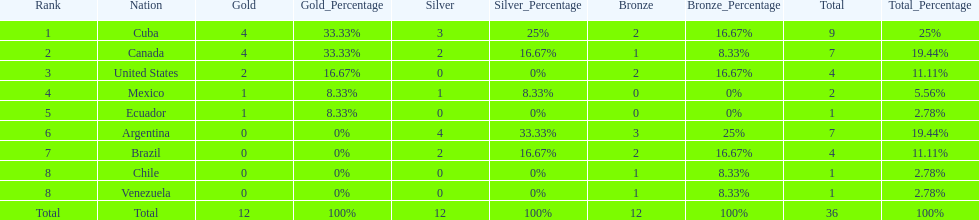Who is ranked #1? Cuba. 